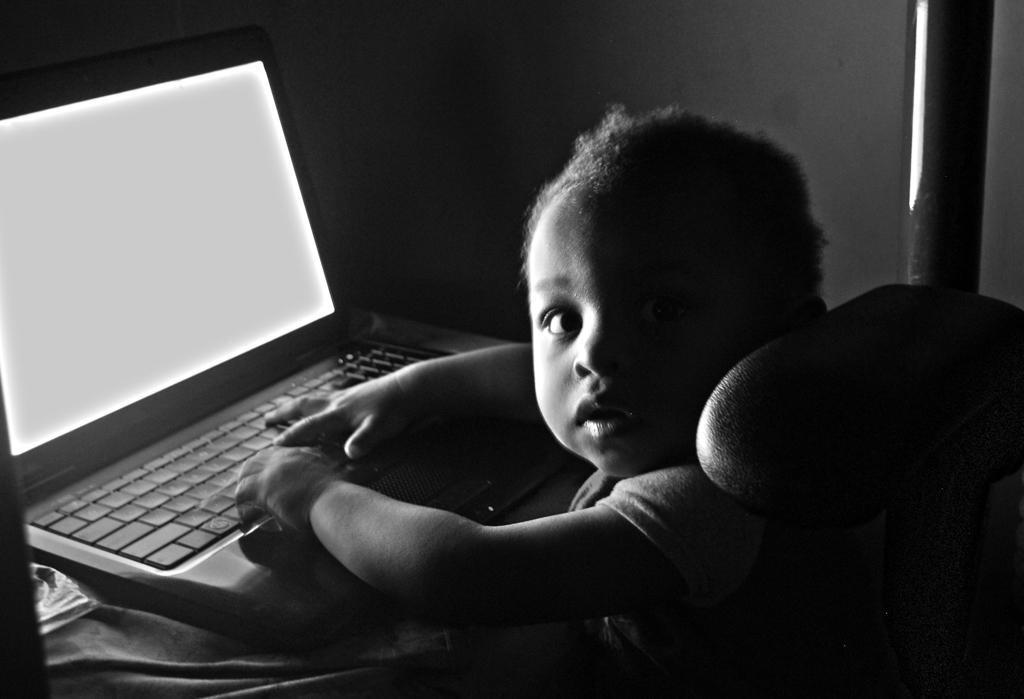What is the color scheme of the image? The image is black and white. Who is present in the image? There is a kid in the image. What is the kid doing in the image? The kid is sitting on a chair. Where is the chair located in relation to the table? The chair is in front of a table. What object is on the table in the image? There is a laptop on the table. What type of soup is being served in the library in the image? There is no soup or library present in the image; it features a kid sitting on a chair in front of a table with a laptop. 